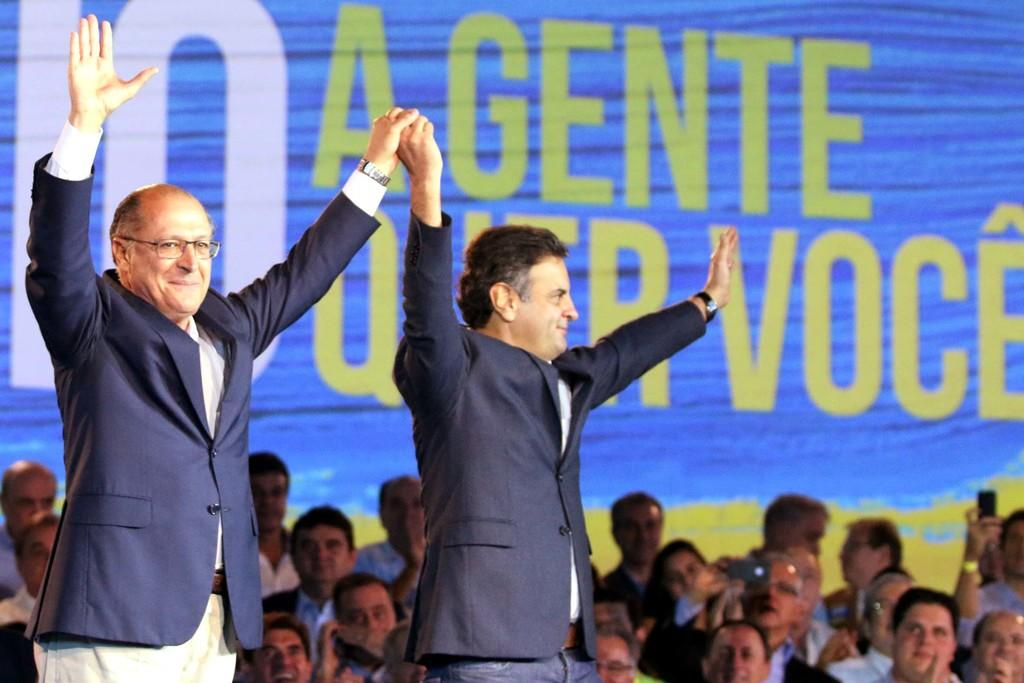What are the people in the image wearing? The persons in the image are wearing clothes. Can you describe the interaction between two of the persons in the image? Two persons are holding hands in the middle of the image. What can be seen in the background of the image? There is some text visible in the background of the image. What is the name of the daughter of the person on the left in the image? There is no mention of a daughter or any names in the image, so it cannot be determined. 